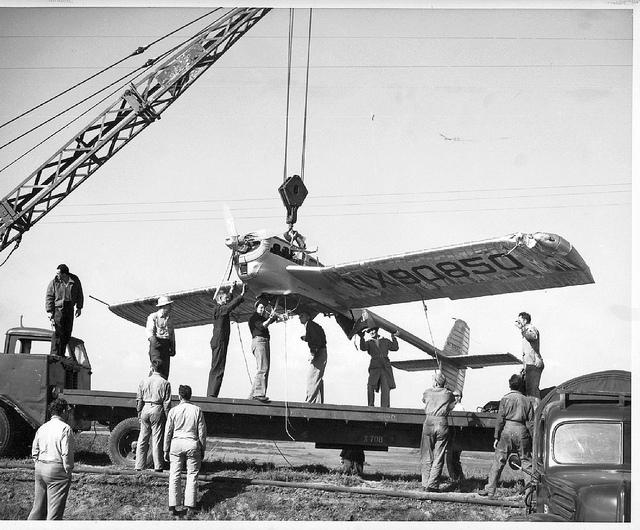Is the picture black and white?
Short answer required. Yes. What is being lifted by the crane?
Give a very brief answer. Plane. What is the first letter on the planes wing?
Concise answer only. N. 